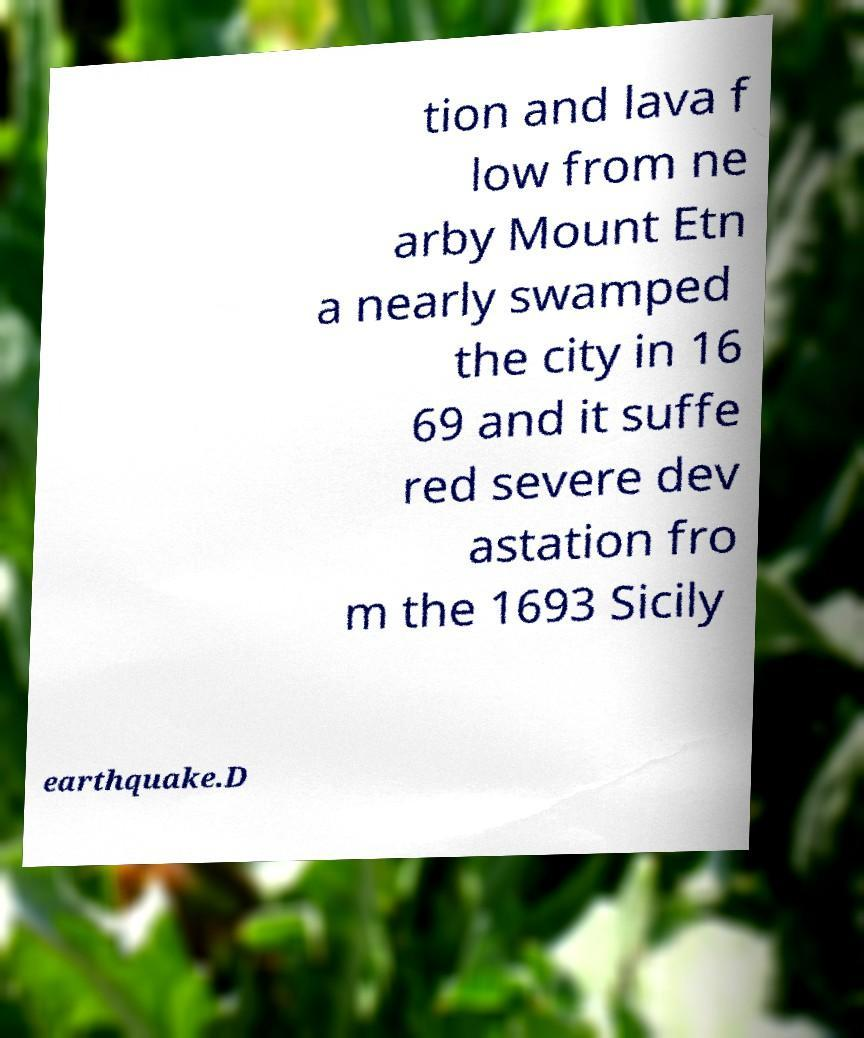For documentation purposes, I need the text within this image transcribed. Could you provide that? tion and lava f low from ne arby Mount Etn a nearly swamped the city in 16 69 and it suffe red severe dev astation fro m the 1693 Sicily earthquake.D 